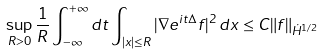<formula> <loc_0><loc_0><loc_500><loc_500>\sup _ { R > 0 } \frac { 1 } { R } \int _ { - \infty } ^ { + \infty } d t \int _ { | x | \leq R } | \nabla e ^ { i t \Delta } f | ^ { 2 } \, d x \leq C \| f \| _ { \dot { H } ^ { 1 / 2 } }</formula> 